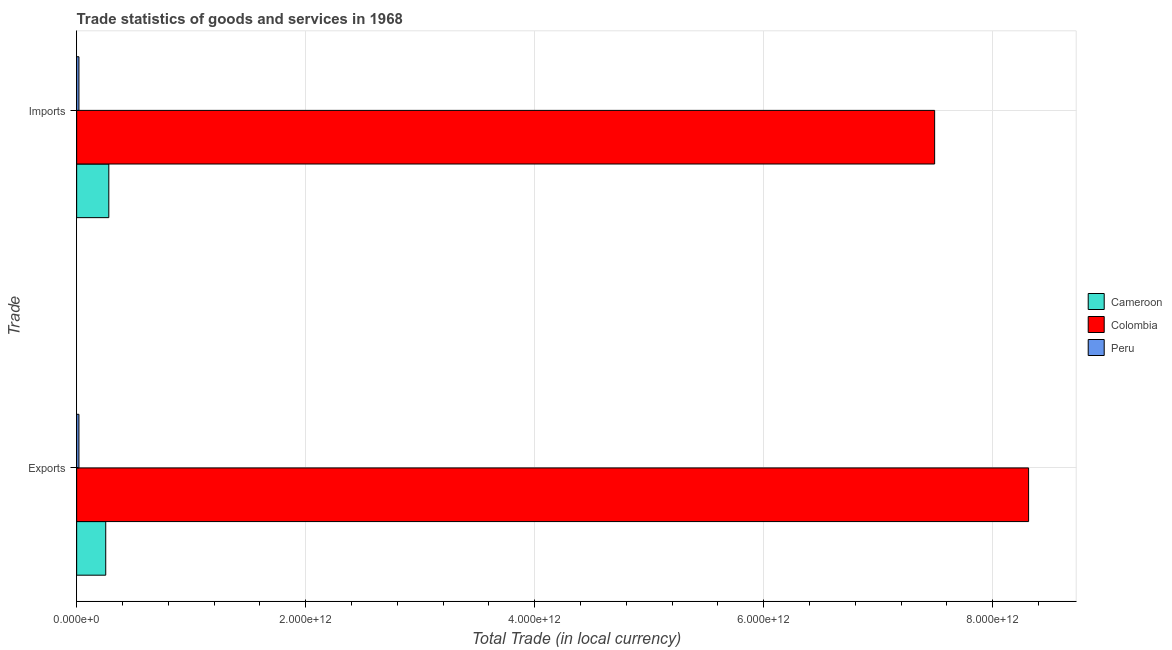How many groups of bars are there?
Give a very brief answer. 2. How many bars are there on the 1st tick from the bottom?
Provide a short and direct response. 3. What is the label of the 2nd group of bars from the top?
Keep it short and to the point. Exports. What is the export of goods and services in Cameroon?
Give a very brief answer. 2.54e+11. Across all countries, what is the maximum export of goods and services?
Your answer should be very brief. 8.31e+12. Across all countries, what is the minimum imports of goods and services?
Provide a short and direct response. 1.99e+1. What is the total imports of goods and services in the graph?
Keep it short and to the point. 7.79e+12. What is the difference between the imports of goods and services in Cameroon and that in Peru?
Provide a succinct answer. 2.61e+11. What is the difference between the imports of goods and services in Cameroon and the export of goods and services in Colombia?
Your response must be concise. -8.03e+12. What is the average export of goods and services per country?
Provide a short and direct response. 2.86e+12. What is the difference between the export of goods and services and imports of goods and services in Cameroon?
Your answer should be very brief. -2.69e+1. What is the ratio of the imports of goods and services in Cameroon to that in Colombia?
Keep it short and to the point. 0.04. Is the imports of goods and services in Colombia less than that in Peru?
Offer a terse response. No. In how many countries, is the imports of goods and services greater than the average imports of goods and services taken over all countries?
Give a very brief answer. 1. What does the 1st bar from the top in Imports represents?
Offer a very short reply. Peru. What does the 1st bar from the bottom in Imports represents?
Your answer should be very brief. Cameroon. How many bars are there?
Your answer should be compact. 6. How many countries are there in the graph?
Your answer should be very brief. 3. What is the difference between two consecutive major ticks on the X-axis?
Provide a short and direct response. 2.00e+12. Are the values on the major ticks of X-axis written in scientific E-notation?
Your answer should be compact. Yes. Does the graph contain any zero values?
Provide a succinct answer. No. What is the title of the graph?
Your response must be concise. Trade statistics of goods and services in 1968. What is the label or title of the X-axis?
Give a very brief answer. Total Trade (in local currency). What is the label or title of the Y-axis?
Offer a terse response. Trade. What is the Total Trade (in local currency) in Cameroon in Exports?
Ensure brevity in your answer.  2.54e+11. What is the Total Trade (in local currency) of Colombia in Exports?
Your response must be concise. 8.31e+12. What is the Total Trade (in local currency) in Peru in Exports?
Your answer should be very brief. 1.99e+1. What is the Total Trade (in local currency) of Cameroon in Imports?
Offer a terse response. 2.81e+11. What is the Total Trade (in local currency) in Colombia in Imports?
Make the answer very short. 7.49e+12. What is the Total Trade (in local currency) in Peru in Imports?
Your answer should be very brief. 1.99e+1. Across all Trade, what is the maximum Total Trade (in local currency) in Cameroon?
Your response must be concise. 2.81e+11. Across all Trade, what is the maximum Total Trade (in local currency) in Colombia?
Give a very brief answer. 8.31e+12. Across all Trade, what is the maximum Total Trade (in local currency) in Peru?
Provide a succinct answer. 1.99e+1. Across all Trade, what is the minimum Total Trade (in local currency) in Cameroon?
Make the answer very short. 2.54e+11. Across all Trade, what is the minimum Total Trade (in local currency) of Colombia?
Ensure brevity in your answer.  7.49e+12. Across all Trade, what is the minimum Total Trade (in local currency) in Peru?
Your response must be concise. 1.99e+1. What is the total Total Trade (in local currency) of Cameroon in the graph?
Provide a short and direct response. 5.35e+11. What is the total Total Trade (in local currency) of Colombia in the graph?
Your answer should be very brief. 1.58e+13. What is the total Total Trade (in local currency) in Peru in the graph?
Your answer should be compact. 3.99e+1. What is the difference between the Total Trade (in local currency) in Cameroon in Exports and that in Imports?
Your answer should be very brief. -2.69e+1. What is the difference between the Total Trade (in local currency) in Colombia in Exports and that in Imports?
Keep it short and to the point. 8.21e+11. What is the difference between the Total Trade (in local currency) in Peru in Exports and that in Imports?
Your response must be concise. 2.89e+07. What is the difference between the Total Trade (in local currency) of Cameroon in Exports and the Total Trade (in local currency) of Colombia in Imports?
Give a very brief answer. -7.24e+12. What is the difference between the Total Trade (in local currency) of Cameroon in Exports and the Total Trade (in local currency) of Peru in Imports?
Make the answer very short. 2.34e+11. What is the difference between the Total Trade (in local currency) in Colombia in Exports and the Total Trade (in local currency) in Peru in Imports?
Your answer should be very brief. 8.29e+12. What is the average Total Trade (in local currency) in Cameroon per Trade?
Your answer should be compact. 2.67e+11. What is the average Total Trade (in local currency) in Colombia per Trade?
Ensure brevity in your answer.  7.90e+12. What is the average Total Trade (in local currency) in Peru per Trade?
Make the answer very short. 1.99e+1. What is the difference between the Total Trade (in local currency) of Cameroon and Total Trade (in local currency) of Colombia in Exports?
Ensure brevity in your answer.  -8.06e+12. What is the difference between the Total Trade (in local currency) in Cameroon and Total Trade (in local currency) in Peru in Exports?
Keep it short and to the point. 2.34e+11. What is the difference between the Total Trade (in local currency) in Colombia and Total Trade (in local currency) in Peru in Exports?
Offer a very short reply. 8.29e+12. What is the difference between the Total Trade (in local currency) in Cameroon and Total Trade (in local currency) in Colombia in Imports?
Give a very brief answer. -7.21e+12. What is the difference between the Total Trade (in local currency) of Cameroon and Total Trade (in local currency) of Peru in Imports?
Ensure brevity in your answer.  2.61e+11. What is the difference between the Total Trade (in local currency) of Colombia and Total Trade (in local currency) of Peru in Imports?
Ensure brevity in your answer.  7.47e+12. What is the ratio of the Total Trade (in local currency) in Cameroon in Exports to that in Imports?
Ensure brevity in your answer.  0.9. What is the ratio of the Total Trade (in local currency) of Colombia in Exports to that in Imports?
Offer a terse response. 1.11. What is the difference between the highest and the second highest Total Trade (in local currency) of Cameroon?
Offer a very short reply. 2.69e+1. What is the difference between the highest and the second highest Total Trade (in local currency) in Colombia?
Offer a very short reply. 8.21e+11. What is the difference between the highest and the second highest Total Trade (in local currency) of Peru?
Provide a short and direct response. 2.89e+07. What is the difference between the highest and the lowest Total Trade (in local currency) of Cameroon?
Your answer should be compact. 2.69e+1. What is the difference between the highest and the lowest Total Trade (in local currency) of Colombia?
Keep it short and to the point. 8.21e+11. What is the difference between the highest and the lowest Total Trade (in local currency) in Peru?
Offer a very short reply. 2.89e+07. 